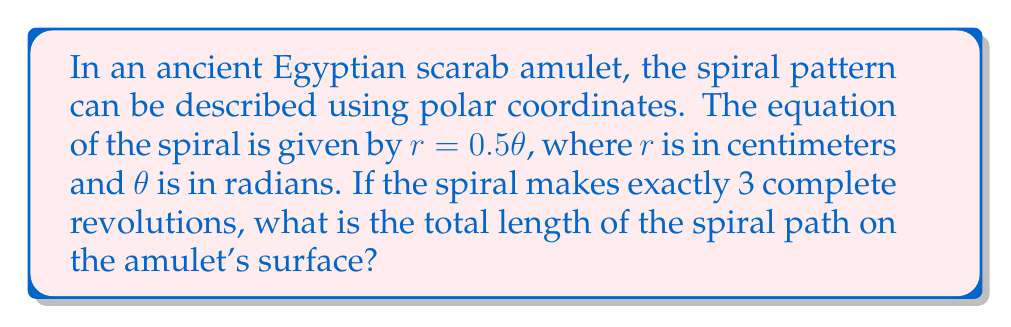Teach me how to tackle this problem. To solve this problem, we'll follow these steps:

1) First, we need to determine the range of $\theta$. Since the spiral makes 3 complete revolutions, $\theta$ goes from 0 to $6\pi$ radians.

2) The formula for the length of a curve in polar coordinates is:

   $$L = \int_a^b \sqrt{r^2 + \left(\frac{dr}{d\theta}\right)^2} d\theta$$

3) In our case, $r = 0.5\theta$, so $\frac{dr}{d\theta} = 0.5$

4) Substituting these into the formula:

   $$L = \int_0^{6\pi} \sqrt{(0.5\theta)^2 + (0.5)^2} d\theta$$

5) Simplifying inside the square root:

   $$L = \int_0^{6\pi} \sqrt{0.25\theta^2 + 0.25} d\theta$$

6) Factor out 0.25:

   $$L = \int_0^{6\pi} 0.5\sqrt{\theta^2 + 1} d\theta$$

7) This integral doesn't have an elementary antiderivative. We can solve it using the hyperbolic functions:

   $$L = 0.5 [\theta \sqrt{\theta^2 + 1} + \ln(\theta + \sqrt{\theta^2 + 1})]_0^{6\pi}$$

8) Evaluating at the limits:

   $$L = 0.5 [6\pi \sqrt{36\pi^2 + 1} + \ln(6\pi + \sqrt{36\pi^2 + 1}) - (0 + \ln(1))]$$

9) Simplifying:

   $$L \approx 0.5 [6\pi \sqrt{36\pi^2 + 1} + \ln(6\pi + \sqrt{36\pi^2 + 1})]$$

10) Calculating this numerically:

    $$L \approx 57.249 \text{ cm}$$

Thus, the total length of the spiral path on the amulet's surface is approximately 57.249 cm.
Answer: $57.249 \text{ cm}$ (rounded to three decimal places) 